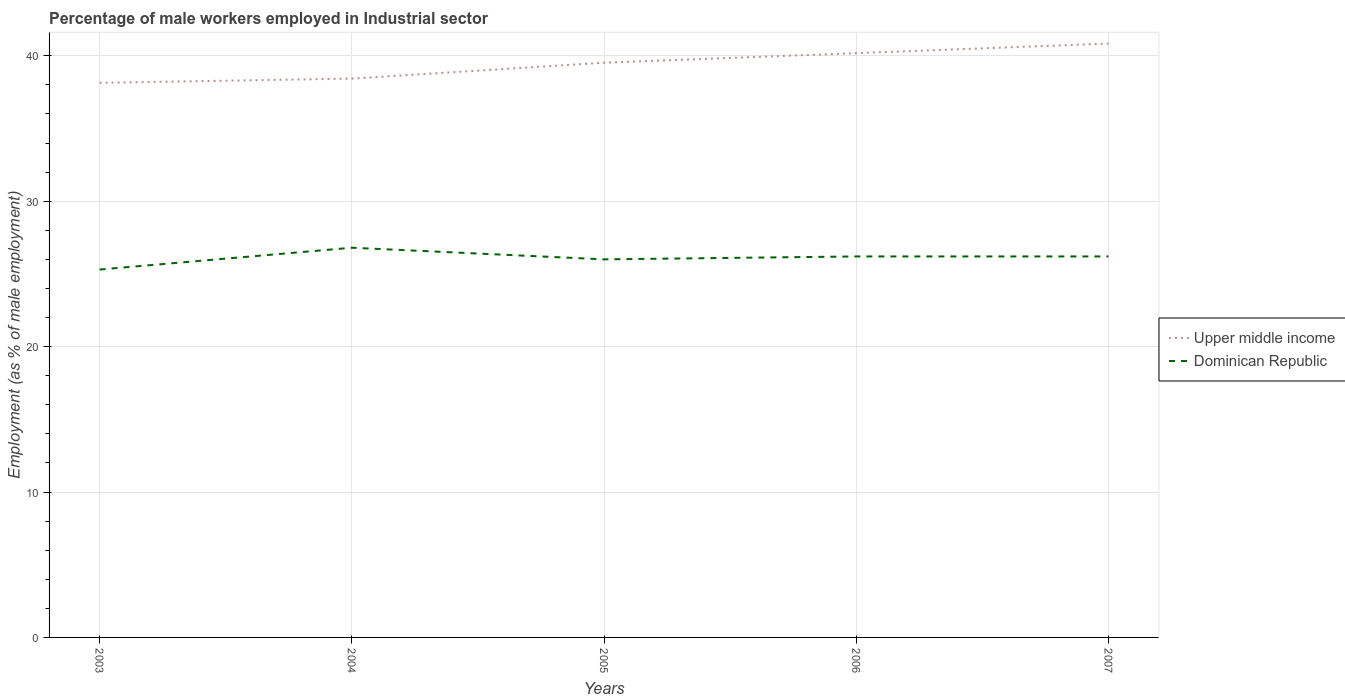How many different coloured lines are there?
Keep it short and to the point. 2. Does the line corresponding to Dominican Republic intersect with the line corresponding to Upper middle income?
Your answer should be compact. No. Across all years, what is the maximum percentage of male workers employed in Industrial sector in Upper middle income?
Make the answer very short. 38.14. What is the total percentage of male workers employed in Industrial sector in Dominican Republic in the graph?
Offer a terse response. 0.6. What is the difference between the highest and the lowest percentage of male workers employed in Industrial sector in Upper middle income?
Provide a succinct answer. 3. Is the percentage of male workers employed in Industrial sector in Upper middle income strictly greater than the percentage of male workers employed in Industrial sector in Dominican Republic over the years?
Ensure brevity in your answer.  No. What is the difference between two consecutive major ticks on the Y-axis?
Provide a short and direct response. 10. Are the values on the major ticks of Y-axis written in scientific E-notation?
Your response must be concise. No. Does the graph contain any zero values?
Make the answer very short. No. Does the graph contain grids?
Offer a terse response. Yes. How many legend labels are there?
Your answer should be compact. 2. What is the title of the graph?
Keep it short and to the point. Percentage of male workers employed in Industrial sector. What is the label or title of the Y-axis?
Keep it short and to the point. Employment (as % of male employment). What is the Employment (as % of male employment) in Upper middle income in 2003?
Ensure brevity in your answer.  38.14. What is the Employment (as % of male employment) of Dominican Republic in 2003?
Your response must be concise. 25.3. What is the Employment (as % of male employment) in Upper middle income in 2004?
Provide a succinct answer. 38.43. What is the Employment (as % of male employment) in Dominican Republic in 2004?
Ensure brevity in your answer.  26.8. What is the Employment (as % of male employment) in Upper middle income in 2005?
Offer a very short reply. 39.52. What is the Employment (as % of male employment) of Upper middle income in 2006?
Ensure brevity in your answer.  40.18. What is the Employment (as % of male employment) in Dominican Republic in 2006?
Provide a succinct answer. 26.2. What is the Employment (as % of male employment) in Upper middle income in 2007?
Your answer should be very brief. 40.84. What is the Employment (as % of male employment) of Dominican Republic in 2007?
Your answer should be very brief. 26.2. Across all years, what is the maximum Employment (as % of male employment) of Upper middle income?
Make the answer very short. 40.84. Across all years, what is the maximum Employment (as % of male employment) of Dominican Republic?
Your answer should be compact. 26.8. Across all years, what is the minimum Employment (as % of male employment) of Upper middle income?
Your answer should be compact. 38.14. Across all years, what is the minimum Employment (as % of male employment) of Dominican Republic?
Your answer should be very brief. 25.3. What is the total Employment (as % of male employment) of Upper middle income in the graph?
Your answer should be compact. 197.11. What is the total Employment (as % of male employment) in Dominican Republic in the graph?
Keep it short and to the point. 130.5. What is the difference between the Employment (as % of male employment) in Upper middle income in 2003 and that in 2004?
Ensure brevity in your answer.  -0.29. What is the difference between the Employment (as % of male employment) of Dominican Republic in 2003 and that in 2004?
Offer a terse response. -1.5. What is the difference between the Employment (as % of male employment) in Upper middle income in 2003 and that in 2005?
Keep it short and to the point. -1.39. What is the difference between the Employment (as % of male employment) of Upper middle income in 2003 and that in 2006?
Ensure brevity in your answer.  -2.04. What is the difference between the Employment (as % of male employment) in Upper middle income in 2003 and that in 2007?
Ensure brevity in your answer.  -2.7. What is the difference between the Employment (as % of male employment) in Dominican Republic in 2003 and that in 2007?
Provide a succinct answer. -0.9. What is the difference between the Employment (as % of male employment) in Upper middle income in 2004 and that in 2005?
Provide a short and direct response. -1.09. What is the difference between the Employment (as % of male employment) of Upper middle income in 2004 and that in 2006?
Give a very brief answer. -1.75. What is the difference between the Employment (as % of male employment) in Dominican Republic in 2004 and that in 2006?
Provide a succinct answer. 0.6. What is the difference between the Employment (as % of male employment) of Upper middle income in 2004 and that in 2007?
Give a very brief answer. -2.41. What is the difference between the Employment (as % of male employment) in Upper middle income in 2005 and that in 2006?
Your response must be concise. -0.66. What is the difference between the Employment (as % of male employment) in Dominican Republic in 2005 and that in 2006?
Offer a terse response. -0.2. What is the difference between the Employment (as % of male employment) in Upper middle income in 2005 and that in 2007?
Keep it short and to the point. -1.32. What is the difference between the Employment (as % of male employment) of Dominican Republic in 2005 and that in 2007?
Keep it short and to the point. -0.2. What is the difference between the Employment (as % of male employment) in Upper middle income in 2006 and that in 2007?
Offer a very short reply. -0.66. What is the difference between the Employment (as % of male employment) in Dominican Republic in 2006 and that in 2007?
Give a very brief answer. 0. What is the difference between the Employment (as % of male employment) in Upper middle income in 2003 and the Employment (as % of male employment) in Dominican Republic in 2004?
Keep it short and to the point. 11.34. What is the difference between the Employment (as % of male employment) in Upper middle income in 2003 and the Employment (as % of male employment) in Dominican Republic in 2005?
Your response must be concise. 12.14. What is the difference between the Employment (as % of male employment) in Upper middle income in 2003 and the Employment (as % of male employment) in Dominican Republic in 2006?
Your answer should be very brief. 11.94. What is the difference between the Employment (as % of male employment) of Upper middle income in 2003 and the Employment (as % of male employment) of Dominican Republic in 2007?
Give a very brief answer. 11.94. What is the difference between the Employment (as % of male employment) in Upper middle income in 2004 and the Employment (as % of male employment) in Dominican Republic in 2005?
Your response must be concise. 12.43. What is the difference between the Employment (as % of male employment) of Upper middle income in 2004 and the Employment (as % of male employment) of Dominican Republic in 2006?
Provide a short and direct response. 12.23. What is the difference between the Employment (as % of male employment) of Upper middle income in 2004 and the Employment (as % of male employment) of Dominican Republic in 2007?
Your answer should be very brief. 12.23. What is the difference between the Employment (as % of male employment) in Upper middle income in 2005 and the Employment (as % of male employment) in Dominican Republic in 2006?
Give a very brief answer. 13.32. What is the difference between the Employment (as % of male employment) in Upper middle income in 2005 and the Employment (as % of male employment) in Dominican Republic in 2007?
Keep it short and to the point. 13.32. What is the difference between the Employment (as % of male employment) in Upper middle income in 2006 and the Employment (as % of male employment) in Dominican Republic in 2007?
Provide a short and direct response. 13.98. What is the average Employment (as % of male employment) of Upper middle income per year?
Offer a very short reply. 39.42. What is the average Employment (as % of male employment) of Dominican Republic per year?
Offer a very short reply. 26.1. In the year 2003, what is the difference between the Employment (as % of male employment) of Upper middle income and Employment (as % of male employment) of Dominican Republic?
Keep it short and to the point. 12.84. In the year 2004, what is the difference between the Employment (as % of male employment) of Upper middle income and Employment (as % of male employment) of Dominican Republic?
Ensure brevity in your answer.  11.63. In the year 2005, what is the difference between the Employment (as % of male employment) of Upper middle income and Employment (as % of male employment) of Dominican Republic?
Make the answer very short. 13.52. In the year 2006, what is the difference between the Employment (as % of male employment) in Upper middle income and Employment (as % of male employment) in Dominican Republic?
Ensure brevity in your answer.  13.98. In the year 2007, what is the difference between the Employment (as % of male employment) of Upper middle income and Employment (as % of male employment) of Dominican Republic?
Keep it short and to the point. 14.64. What is the ratio of the Employment (as % of male employment) of Upper middle income in 2003 to that in 2004?
Provide a short and direct response. 0.99. What is the ratio of the Employment (as % of male employment) of Dominican Republic in 2003 to that in 2004?
Provide a succinct answer. 0.94. What is the ratio of the Employment (as % of male employment) of Upper middle income in 2003 to that in 2005?
Your response must be concise. 0.96. What is the ratio of the Employment (as % of male employment) in Dominican Republic in 2003 to that in 2005?
Your answer should be compact. 0.97. What is the ratio of the Employment (as % of male employment) of Upper middle income in 2003 to that in 2006?
Your answer should be compact. 0.95. What is the ratio of the Employment (as % of male employment) of Dominican Republic in 2003 to that in 2006?
Your response must be concise. 0.97. What is the ratio of the Employment (as % of male employment) of Upper middle income in 2003 to that in 2007?
Your answer should be very brief. 0.93. What is the ratio of the Employment (as % of male employment) of Dominican Republic in 2003 to that in 2007?
Your response must be concise. 0.97. What is the ratio of the Employment (as % of male employment) of Upper middle income in 2004 to that in 2005?
Provide a succinct answer. 0.97. What is the ratio of the Employment (as % of male employment) of Dominican Republic in 2004 to that in 2005?
Make the answer very short. 1.03. What is the ratio of the Employment (as % of male employment) in Upper middle income in 2004 to that in 2006?
Your answer should be compact. 0.96. What is the ratio of the Employment (as % of male employment) of Dominican Republic in 2004 to that in 2006?
Keep it short and to the point. 1.02. What is the ratio of the Employment (as % of male employment) in Upper middle income in 2004 to that in 2007?
Keep it short and to the point. 0.94. What is the ratio of the Employment (as % of male employment) of Dominican Republic in 2004 to that in 2007?
Provide a short and direct response. 1.02. What is the ratio of the Employment (as % of male employment) of Upper middle income in 2005 to that in 2006?
Offer a terse response. 0.98. What is the ratio of the Employment (as % of male employment) in Dominican Republic in 2005 to that in 2006?
Your response must be concise. 0.99. What is the ratio of the Employment (as % of male employment) of Upper middle income in 2005 to that in 2007?
Provide a short and direct response. 0.97. What is the ratio of the Employment (as % of male employment) of Dominican Republic in 2005 to that in 2007?
Provide a short and direct response. 0.99. What is the ratio of the Employment (as % of male employment) in Upper middle income in 2006 to that in 2007?
Your answer should be compact. 0.98. What is the ratio of the Employment (as % of male employment) of Dominican Republic in 2006 to that in 2007?
Give a very brief answer. 1. What is the difference between the highest and the second highest Employment (as % of male employment) of Upper middle income?
Provide a succinct answer. 0.66. What is the difference between the highest and the lowest Employment (as % of male employment) of Upper middle income?
Make the answer very short. 2.7. What is the difference between the highest and the lowest Employment (as % of male employment) of Dominican Republic?
Provide a succinct answer. 1.5. 